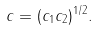<formula> <loc_0><loc_0><loc_500><loc_500>c = ( c _ { 1 } c _ { 2 } ) ^ { 1 / 2 } .</formula> 